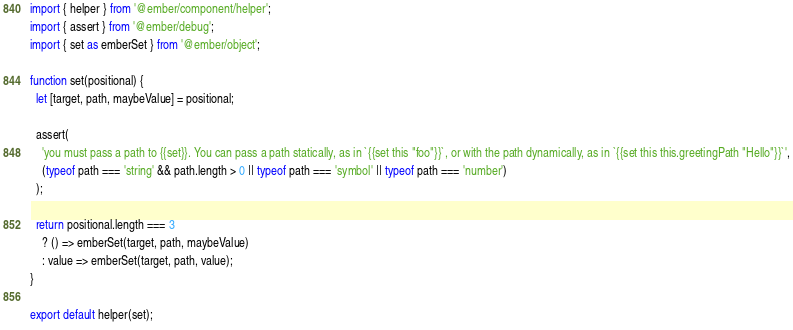Convert code to text. <code><loc_0><loc_0><loc_500><loc_500><_JavaScript_>import { helper } from '@ember/component/helper';
import { assert } from '@ember/debug';
import { set as emberSet } from '@ember/object';

function set(positional) {
  let [target, path, maybeValue] = positional;

  assert(
    'you must pass a path to {{set}}. You can pass a path statically, as in `{{set this "foo"}}`, or with the path dynamically, as in `{{set this this.greetingPath "Hello"}}`',
    (typeof path === 'string' && path.length > 0 || typeof path === 'symbol' || typeof path === 'number')
  );

  return positional.length === 3
    ? () => emberSet(target, path, maybeValue)
    : value => emberSet(target, path, value);
}

export default helper(set);
</code> 